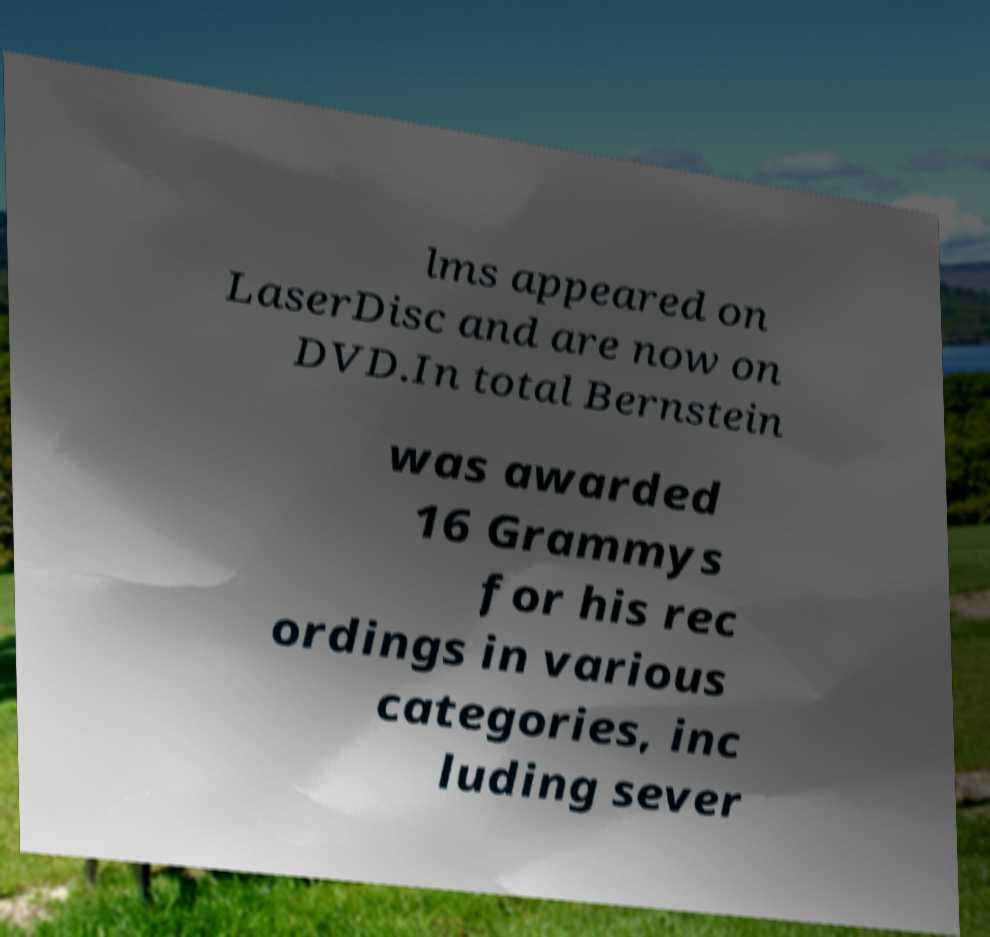Can you accurately transcribe the text from the provided image for me? lms appeared on LaserDisc and are now on DVD.In total Bernstein was awarded 16 Grammys for his rec ordings in various categories, inc luding sever 